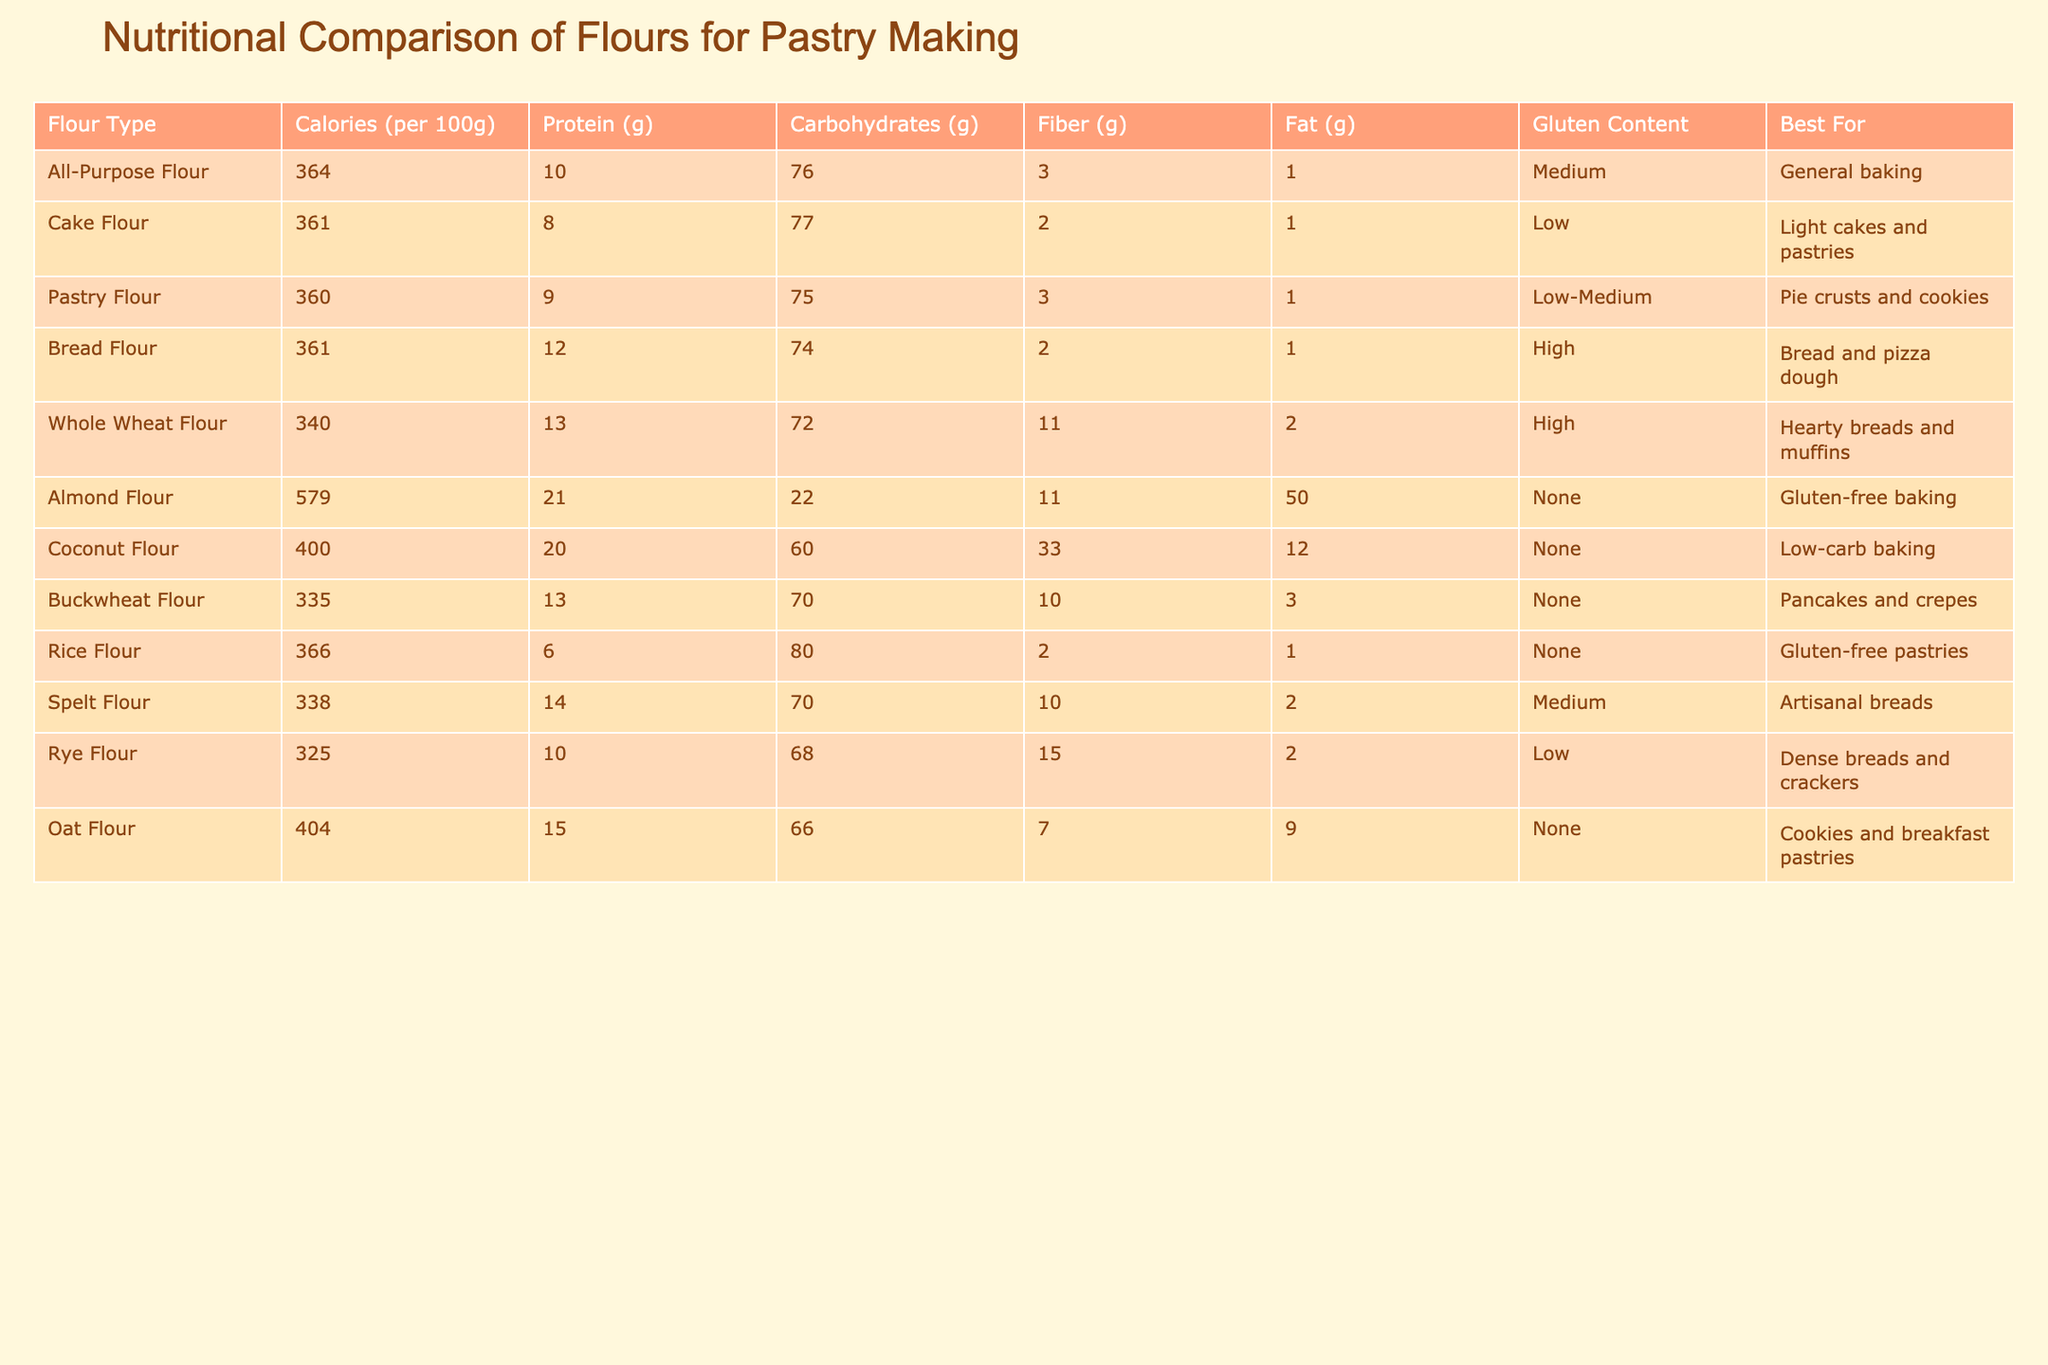What type of flour has the highest calorie content per 100g? By reviewing the "Calories (per 100g)" column, I see that Almond Flour has the highest calorie content with 579 calories.
Answer: Almond Flour Which flour type has the lowest protein content? In the "Protein (g)" column, Rice Flour shows the lowest protein content at 6g.
Answer: Rice Flour How much fiber is present in Whole Wheat Flour compared to Pastry Flour? Whole Wheat Flour contains 11g of fiber and Pastry Flour contains 3g. The difference is calculated as 11g - 3g = 8g.
Answer: 8g Is Bread Flour suitable for gluten-free baking? Checking the "Gluten Content" column, Bread Flour is labeled as High gluten content, making it unsuitable for gluten-free baking.
Answer: No What is the average fat content of the three flours with the highest gluten content (Bread Flour, Whole Wheat Flour, and Spelt Flour)? The fat contents are 1g for Bread Flour, 2g for Whole Wheat Flour, and 2g for Spelt Flour. Adding these gives 1 + 2 + 2 = 5g. Dividing by 3 (since there are three data points) results in an average of 5g / 3 = 1.67g.
Answer: 1.67g 